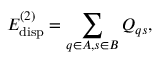<formula> <loc_0><loc_0><loc_500><loc_500>E _ { d i s p } ^ { ( 2 ) } = \sum _ { q \in A , s \in B } Q _ { q s } ,</formula> 